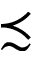<formula> <loc_0><loc_0><loc_500><loc_500>\prec s i m</formula> 